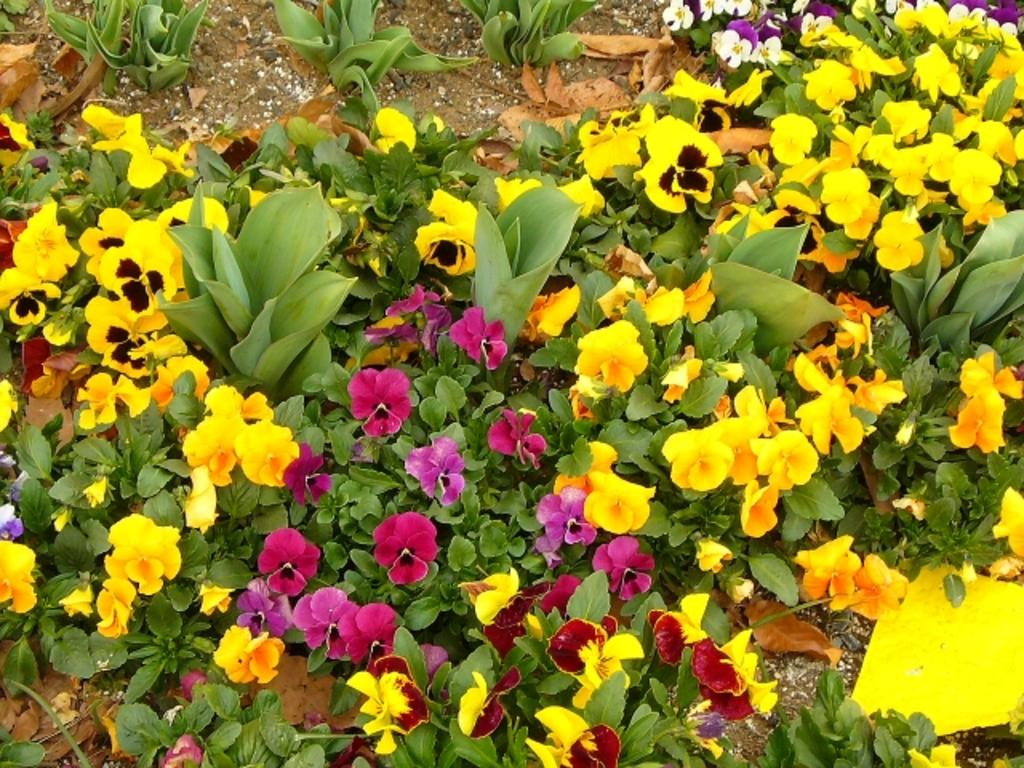What type of living organisms can be seen in the image? Plants can be seen in the image. Are there any specific features of the plants that can be observed? Some of the plants have flowers. What is visible beneath the plants in the image? The ground is visible in the image. Can you tell me how many feet are visible in the image? There are no feet present in the image; it features plants with flowers and visible ground. What type of arithmetic problem can be solved using the plants in the image? There is no arithmetic problem present in the image, as it is a visual representation of plants with flowers and visible ground. 